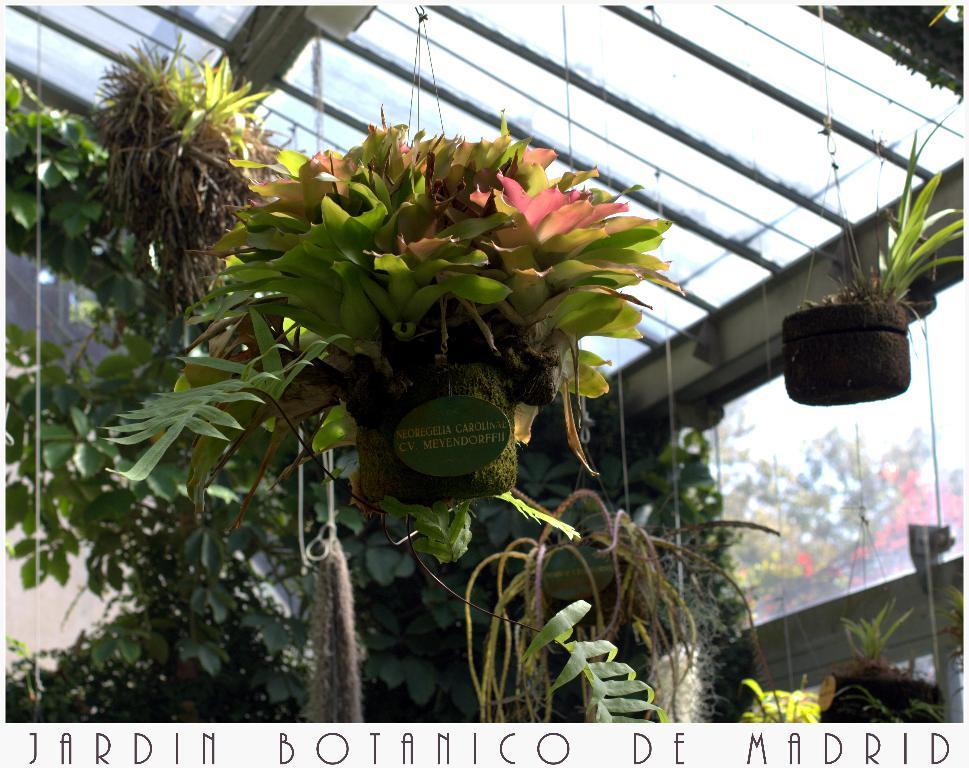What type of objects can be seen in the image? There are plant pots in the image. What is located at the top side of the image? There is a roof at the top side of the image. How many robins are sitting on the cabbage in the image? There is no cabbage or robin present in the image. 